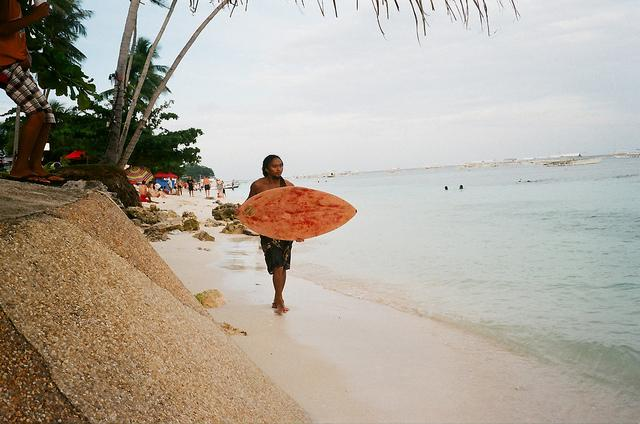Why is the man on the beach holding the object? Please explain your reasoning. to surf. The man wants to take the surfboard out to ride. 